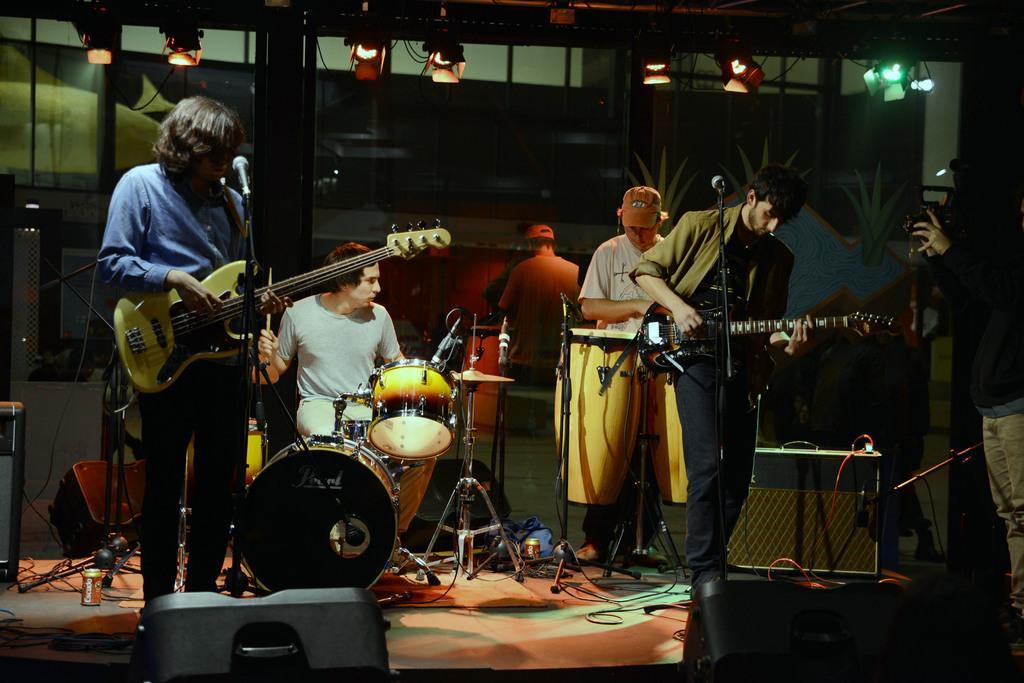In one or two sentences, can you explain what this image depicts? In this image I can see few people standing and playing some musical instruments on the stage. In front of these people I can see two mike stands. On the right side a person is standing and holding a camera in the hands. On the stage, I can see few wires and speakers. At the top of the image there are some lights attached to a metal rod. 